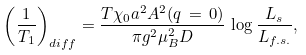Convert formula to latex. <formula><loc_0><loc_0><loc_500><loc_500>\left ( \frac { 1 } { T _ { 1 } } \right ) _ { d i f f } = \frac { T \chi _ { 0 } a ^ { 2 } A ^ { 2 } ( q \, = \, 0 ) } { \pi g ^ { 2 } \mu _ { B } ^ { 2 } D } \, \log \frac { L _ { s } } { L _ { f . s . } } ,</formula> 